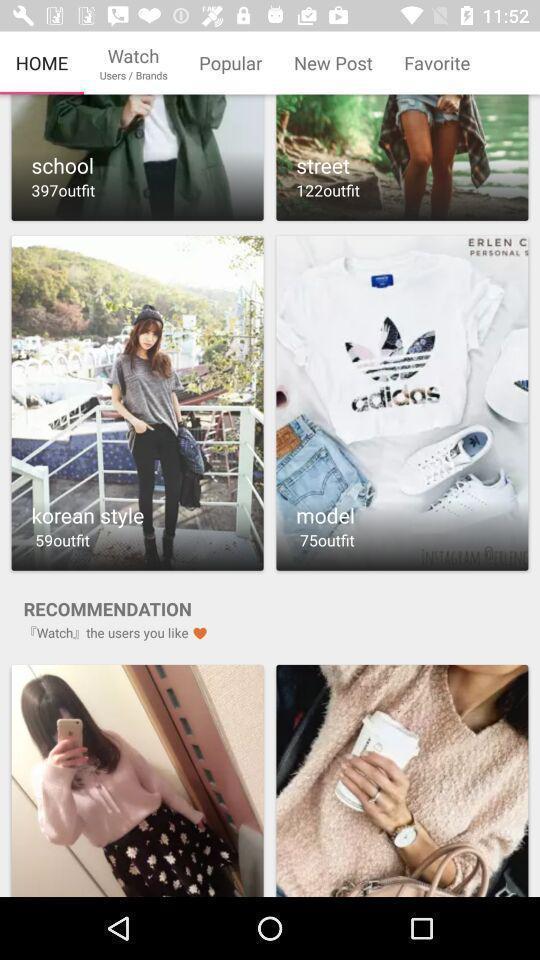Tell me what you see in this picture. Various categories of dresses in the application. 